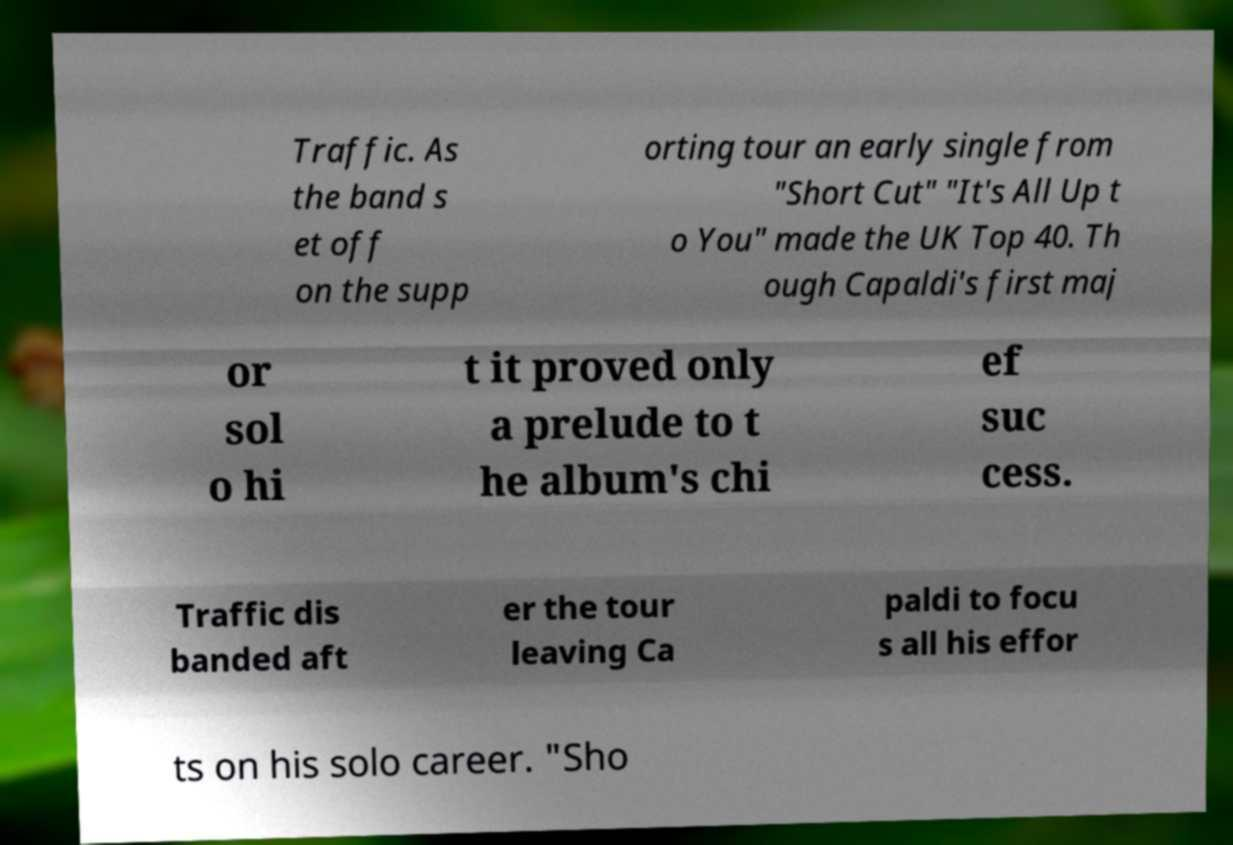I need the written content from this picture converted into text. Can you do that? Traffic. As the band s et off on the supp orting tour an early single from "Short Cut" "It's All Up t o You" made the UK Top 40. Th ough Capaldi's first maj or sol o hi t it proved only a prelude to t he album's chi ef suc cess. Traffic dis banded aft er the tour leaving Ca paldi to focu s all his effor ts on his solo career. "Sho 